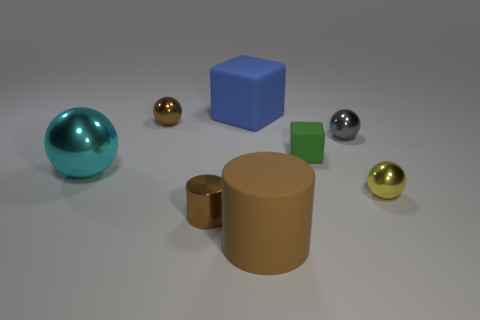Subtract 1 spheres. How many spheres are left? 3 Subtract all small brown cylinders. Subtract all big shiny spheres. How many objects are left? 6 Add 3 cyan shiny things. How many cyan shiny things are left? 4 Add 8 small yellow cylinders. How many small yellow cylinders exist? 8 Subtract 1 blue cubes. How many objects are left? 7 Subtract all cubes. How many objects are left? 6 